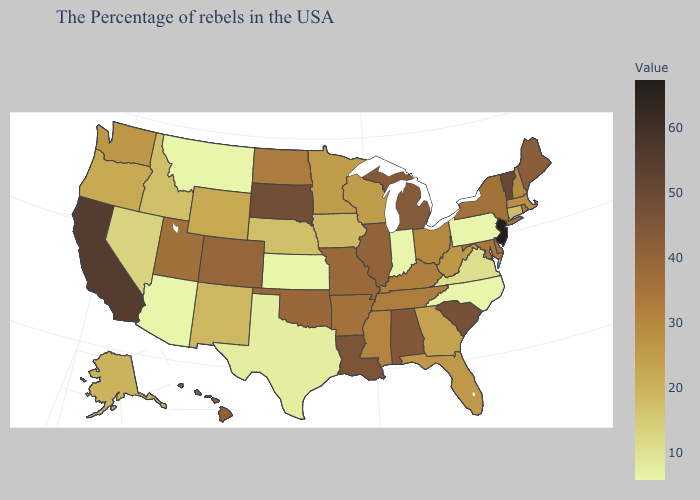Among the states that border Illinois , does Indiana have the lowest value?
Quick response, please. Yes. Does New Jersey have the lowest value in the Northeast?
Concise answer only. No. Is the legend a continuous bar?
Be succinct. Yes. Which states have the lowest value in the USA?
Concise answer only. Pennsylvania, North Carolina, Indiana, Kansas, Montana, Arizona. Among the states that border California , does Nevada have the highest value?
Short answer required. No. Does the map have missing data?
Quick response, please. No. Does South Carolina have the highest value in the South?
Answer briefly. Yes. Does Oregon have a lower value than Montana?
Keep it brief. No. 